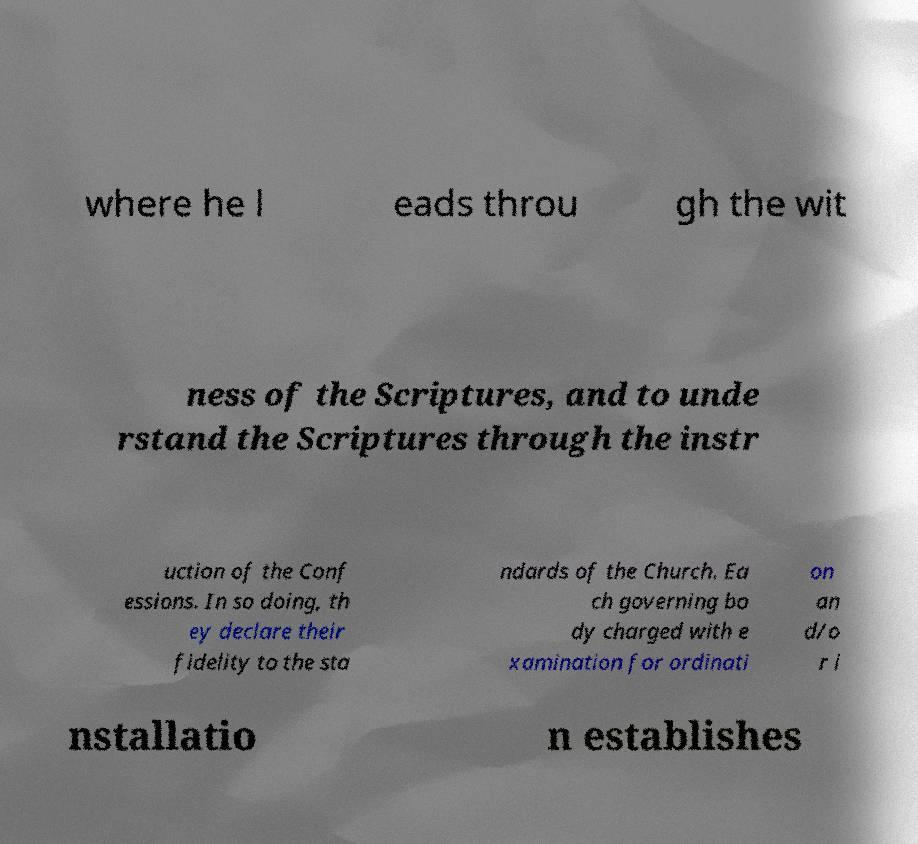I need the written content from this picture converted into text. Can you do that? where he l eads throu gh the wit ness of the Scriptures, and to unde rstand the Scriptures through the instr uction of the Conf essions. In so doing, th ey declare their fidelity to the sta ndards of the Church. Ea ch governing bo dy charged with e xamination for ordinati on an d/o r i nstallatio n establishes 